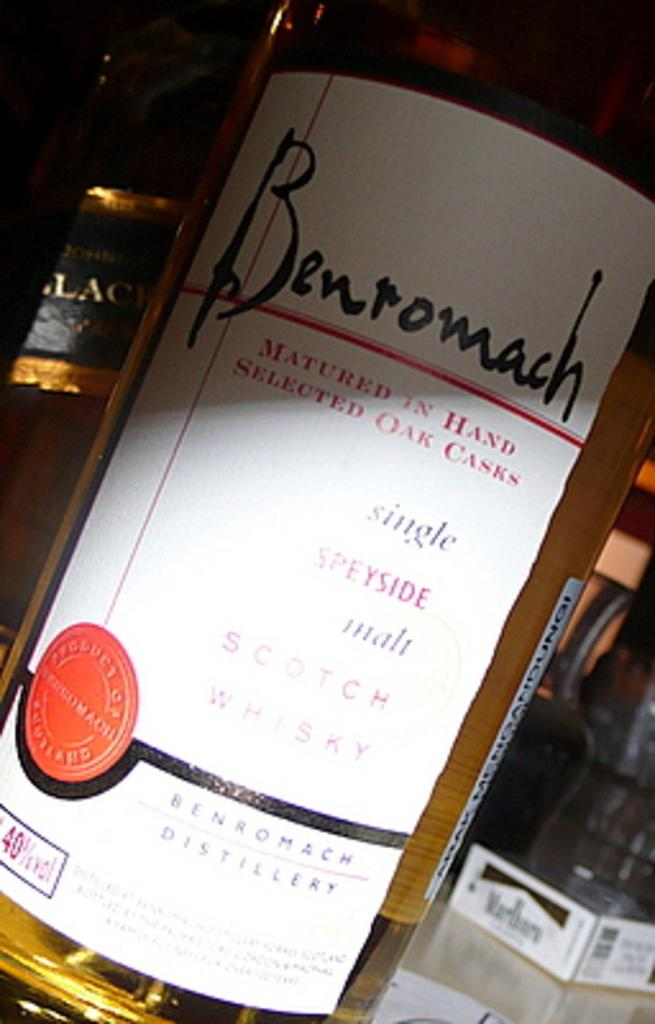<image>
Create a compact narrative representing the image presented. Bottleof Benromach that says "Single Speyside malt Scotch Whiskey". 